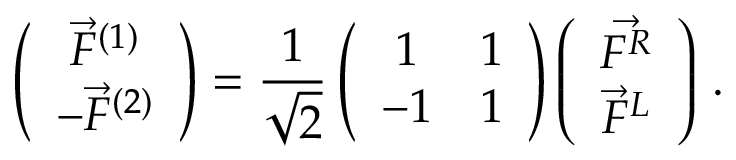<formula> <loc_0><loc_0><loc_500><loc_500>\left ( \begin{array} { c } { { \vec { F } ^ { ( 1 ) } } } \\ { { - \vec { F } ^ { ( 2 ) } } } \end{array} \right ) = \frac { 1 } { \sqrt { 2 } } \left ( \begin{array} { c c } { 1 } & { 1 } \\ { - 1 } & { 1 } \end{array} \right ) \left ( \begin{array} { c } { { \vec { F ^ { R } } } } \\ { { \vec { F } ^ { L } } } \end{array} \right ) \, .</formula> 